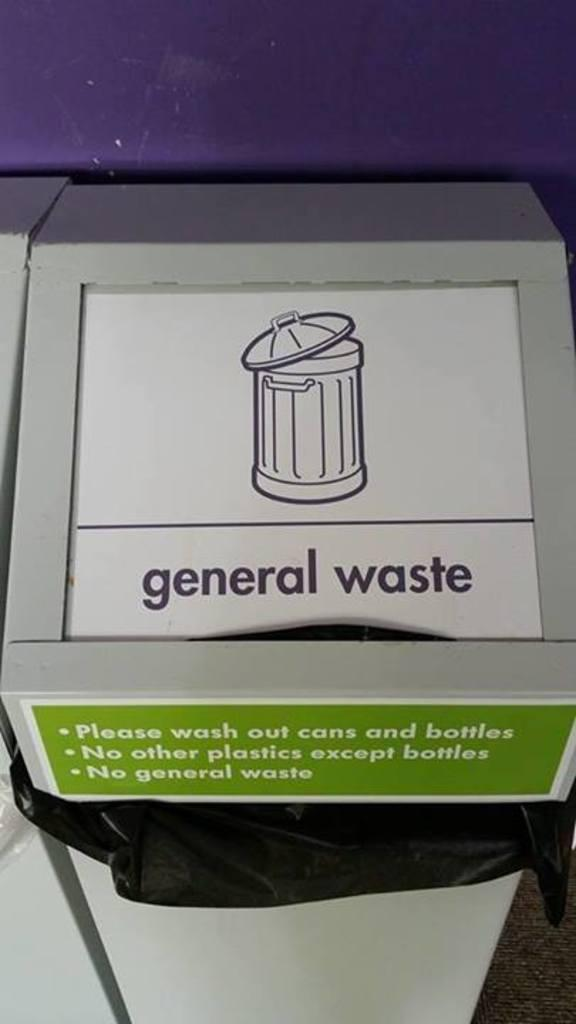<image>
Give a short and clear explanation of the subsequent image. A trash can that says general waste on it sits against a purple wall 